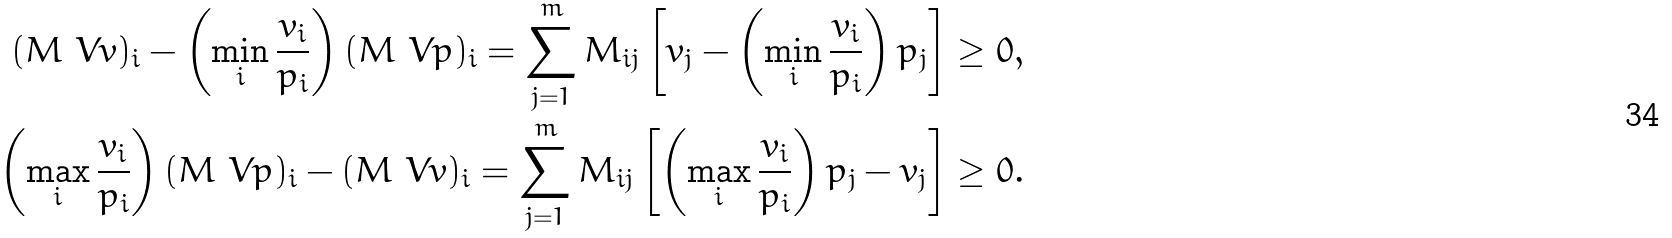Convert formula to latex. <formula><loc_0><loc_0><loc_500><loc_500>( M \ V v ) _ { i } - \left ( \min _ { i } \frac { v _ { i } } { p _ { i } } \right ) ( M \ V p ) _ { i } = \sum _ { j = 1 } ^ { m } M _ { i j } \left [ v _ { j } - \left ( \min _ { i } \frac { v _ { i } } { p _ { i } } \right ) p _ { j } \right ] \geq 0 , \\ \left ( \max _ { i } \frac { v _ { i } } { p _ { i } } \right ) ( M \ V p ) _ { i } - ( M \ V v ) _ { i } = \sum _ { j = 1 } ^ { m } M _ { i j } \left [ \left ( \max _ { i } \frac { v _ { i } } { p _ { i } } \right ) p _ { j } - v _ { j } \right ] \geq 0 .</formula> 